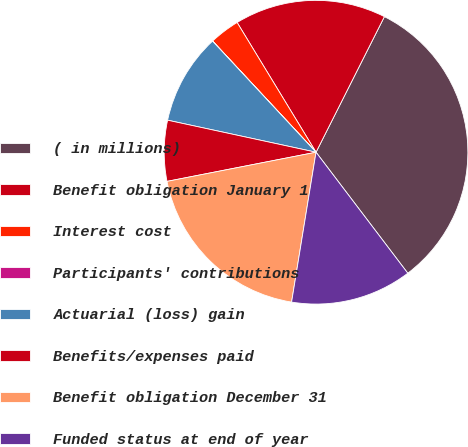Convert chart to OTSL. <chart><loc_0><loc_0><loc_500><loc_500><pie_chart><fcel>( in millions)<fcel>Benefit obligation January 1<fcel>Interest cost<fcel>Participants' contributions<fcel>Actuarial (loss) gain<fcel>Benefits/expenses paid<fcel>Benefit obligation December 31<fcel>Funded status at end of year<nl><fcel>32.24%<fcel>16.13%<fcel>3.23%<fcel>0.01%<fcel>9.68%<fcel>6.46%<fcel>19.35%<fcel>12.9%<nl></chart> 